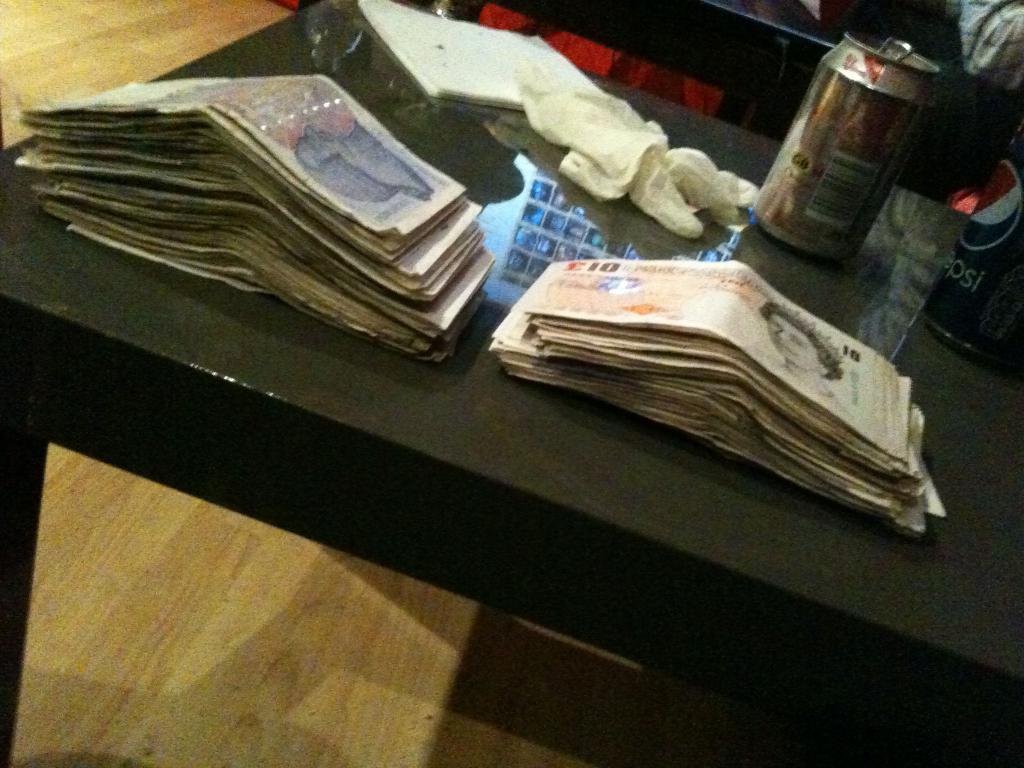Can you describe this image briefly? In this image I can see few currency notes, few tens and few white color objects on the table and the table is in black color. 